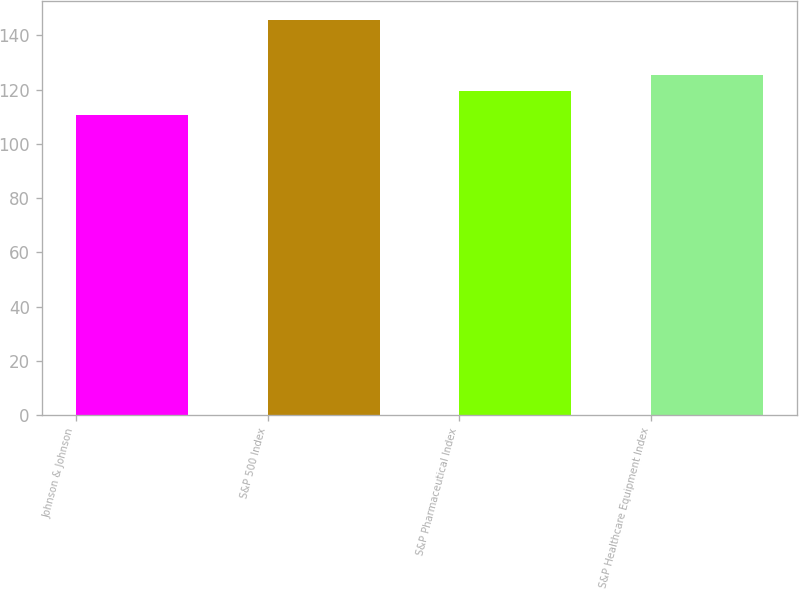Convert chart. <chart><loc_0><loc_0><loc_500><loc_500><bar_chart><fcel>Johnson & Johnson<fcel>S&P 500 Index<fcel>S&P Pharmaceutical Index<fcel>S&P Healthcare Equipment Index<nl><fcel>110.63<fcel>145.49<fcel>119.54<fcel>125.3<nl></chart> 